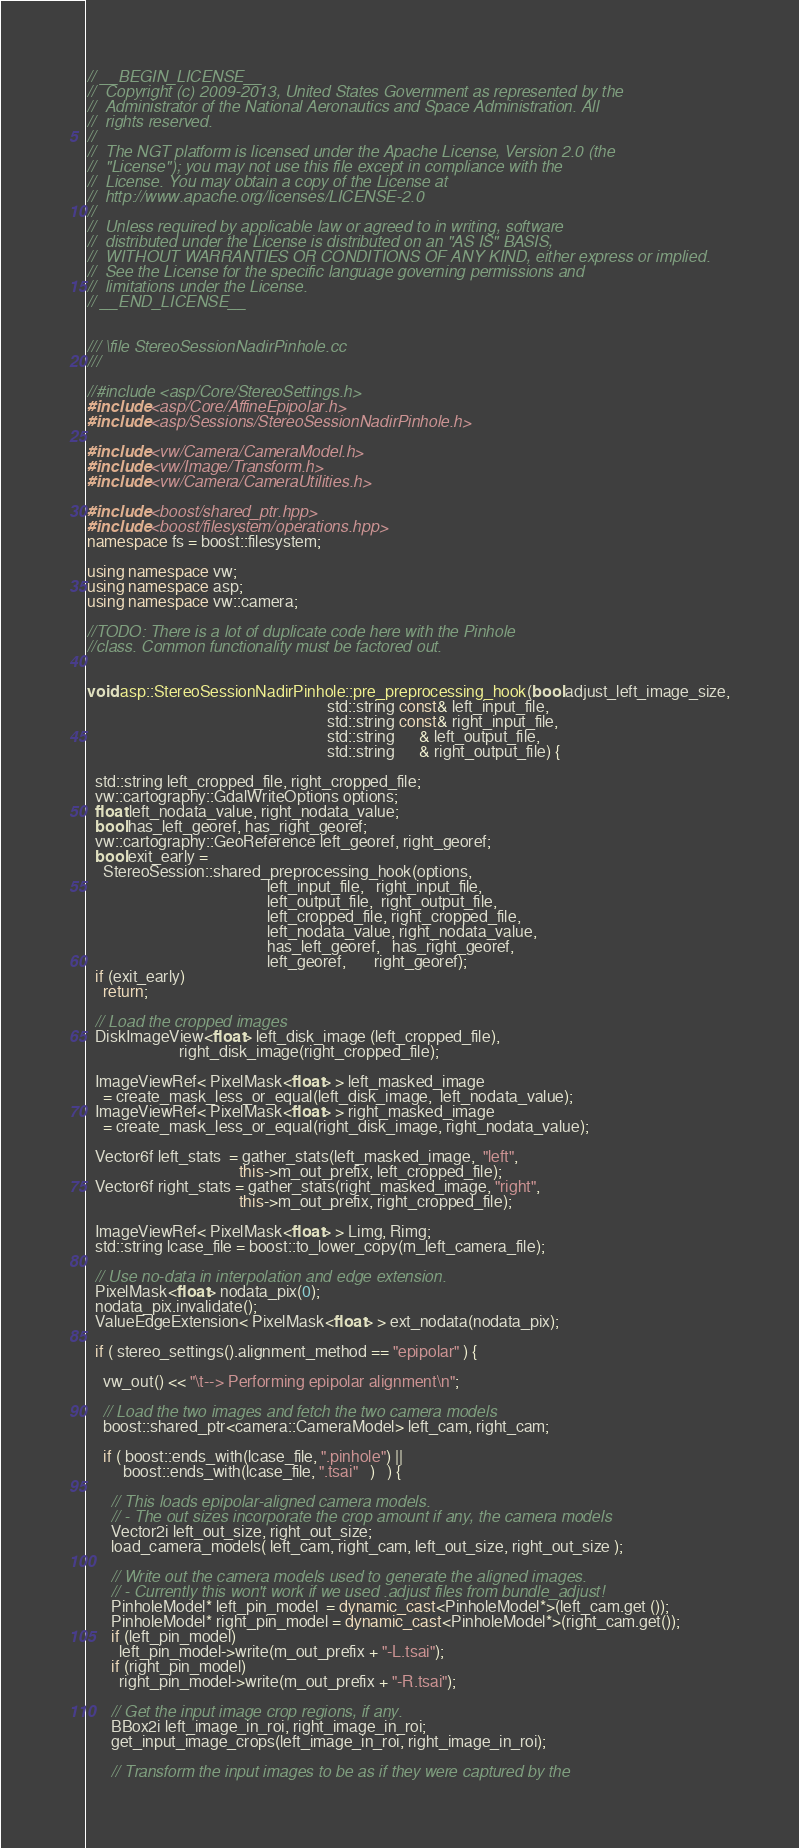Convert code to text. <code><loc_0><loc_0><loc_500><loc_500><_C++_>// __BEGIN_LICENSE__
//  Copyright (c) 2009-2013, United States Government as represented by the
//  Administrator of the National Aeronautics and Space Administration. All
//  rights reserved.
//
//  The NGT platform is licensed under the Apache License, Version 2.0 (the
//  "License"); you may not use this file except in compliance with the
//  License. You may obtain a copy of the License at
//  http://www.apache.org/licenses/LICENSE-2.0
//
//  Unless required by applicable law or agreed to in writing, software
//  distributed under the License is distributed on an "AS IS" BASIS,
//  WITHOUT WARRANTIES OR CONDITIONS OF ANY KIND, either express or implied.
//  See the License for the specific language governing permissions and
//  limitations under the License.
// __END_LICENSE__


/// \file StereoSessionNadirPinhole.cc
///

//#include <asp/Core/StereoSettings.h>
#include <asp/Core/AffineEpipolar.h>
#include <asp/Sessions/StereoSessionNadirPinhole.h>

#include <vw/Camera/CameraModel.h>
#include <vw/Image/Transform.h>
#include <vw/Camera/CameraUtilities.h>

#include <boost/shared_ptr.hpp>
#include <boost/filesystem/operations.hpp>
namespace fs = boost::filesystem;

using namespace vw;
using namespace asp;
using namespace vw::camera;

//TODO: There is a lot of duplicate code here with the Pinhole
//class. Common functionality must be factored out.


void asp::StereoSessionNadirPinhole::pre_preprocessing_hook(bool adjust_left_image_size,
                                                            std::string const& left_input_file,
                                                            std::string const& right_input_file,
                                                            std::string      & left_output_file,
                                                            std::string      & right_output_file) {

  std::string left_cropped_file, right_cropped_file;
  vw::cartography::GdalWriteOptions options;
  float left_nodata_value, right_nodata_value;
  bool has_left_georef, has_right_georef;
  vw::cartography::GeoReference left_georef, right_georef;
  bool exit_early =
    StereoSession::shared_preprocessing_hook(options,
                                             left_input_file,   right_input_file,
                                             left_output_file,  right_output_file,
                                             left_cropped_file, right_cropped_file,
                                             left_nodata_value, right_nodata_value,
                                             has_left_georef,   has_right_georef,
                                             left_georef,       right_georef);
  if (exit_early) 
    return;

  // Load the cropped images
  DiskImageView<float> left_disk_image (left_cropped_file),
                       right_disk_image(right_cropped_file);

  ImageViewRef< PixelMask<float> > left_masked_image
    = create_mask_less_or_equal(left_disk_image,  left_nodata_value);
  ImageViewRef< PixelMask<float> > right_masked_image
    = create_mask_less_or_equal(right_disk_image, right_nodata_value);

  Vector6f left_stats  = gather_stats(left_masked_image,  "left",
                                      this->m_out_prefix, left_cropped_file);
  Vector6f right_stats = gather_stats(right_masked_image, "right",
                                      this->m_out_prefix, right_cropped_file);

  ImageViewRef< PixelMask<float> > Limg, Rimg;
  std::string lcase_file = boost::to_lower_copy(m_left_camera_file);

  // Use no-data in interpolation and edge extension.
  PixelMask<float> nodata_pix(0);
  nodata_pix.invalidate();
  ValueEdgeExtension< PixelMask<float> > ext_nodata(nodata_pix); 

  if ( stereo_settings().alignment_method == "epipolar" ) {

    vw_out() << "\t--> Performing epipolar alignment\n";

    // Load the two images and fetch the two camera models
    boost::shared_ptr<camera::CameraModel> left_cam, right_cam;

    if ( boost::ends_with(lcase_file, ".pinhole") ||
         boost::ends_with(lcase_file, ".tsai"   )   ) {

      // This loads epipolar-aligned camera models.
      // - The out sizes incorporate the crop amount if any, the camera models 
      Vector2i left_out_size, right_out_size;
      load_camera_models( left_cam, right_cam, left_out_size, right_out_size );
      
      // Write out the camera models used to generate the aligned images.
      // - Currently this won't work if we used .adjust files from bundle_adjust!
      PinholeModel* left_pin_model  = dynamic_cast<PinholeModel*>(left_cam.get ());
      PinholeModel* right_pin_model = dynamic_cast<PinholeModel*>(right_cam.get());
      if (left_pin_model)
        left_pin_model->write(m_out_prefix + "-L.tsai");
      if (right_pin_model)
        right_pin_model->write(m_out_prefix + "-R.tsai");

      // Get the input image crop regions, if any.
      BBox2i left_image_in_roi, right_image_in_roi;
      get_input_image_crops(left_image_in_roi, right_image_in_roi);

      // Transform the input images to be as if they were captured by the</code> 